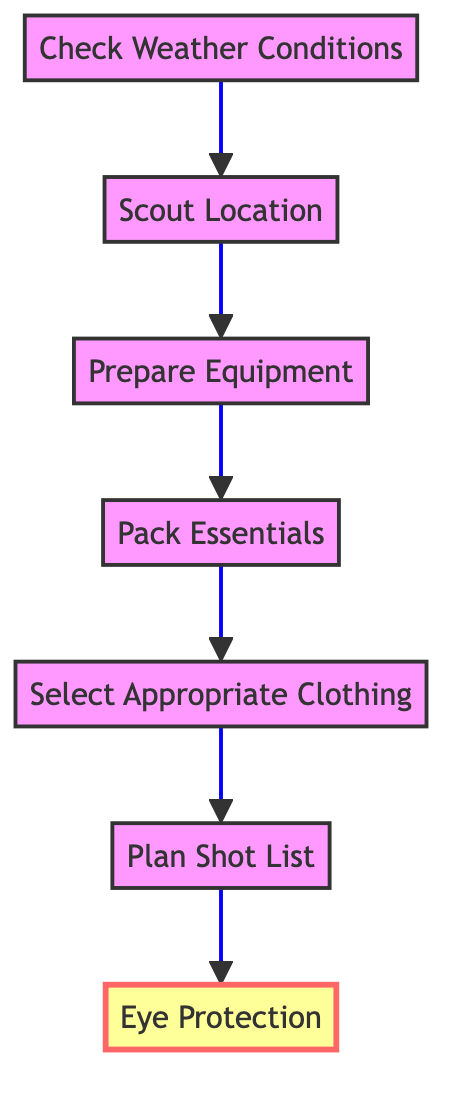What is the first step in the outdoor photoshoot preparation? The first step listed in the diagram is "Check Weather Conditions." This is the initial action that needs to be taken before proceeding to the next steps.
Answer: Check Weather Conditions How many steps are shown in the diagram? There are a total of seven steps illustrated in the diagram. Each step is represented by a node connected in a sequence, starting from "Check Weather Conditions" and ending with "Eye Protection."
Answer: Seven What comes immediately after "Pack Essentials"? The step that comes after "Pack Essentials" is "Select Appropriate Clothing." The sequence in the diagram flows directly from one step to the next.
Answer: Select Appropriate Clothing Which step emphasizes eye protection? The step "Eye Protection" is emphasized in the diagram. It has a bold font and is marked with a special style indicating its importance in the preparation process.
Answer: Eye Protection What relationship exists between "Prepare Equipment" and "Pack Essentials"? The relationship is sequential; "Prepare Equipment" directly leads to "Pack Essentials" as the steps flow from one to the other in a bottom-to-up manner in the diagram.
Answer: Sequential What step includes the suggestion to wear hats and sunglasses? The suggestion to wear hats and sunglasses is included in the step "Select Appropriate Clothing." This step focuses on choosing clothing that is comfortable and appropriate for the weather.
Answer: Select Appropriate Clothing Which node has the largest font size? The node with the largest font size is "Eye Protection." It is designed to stand out, indicating its critical importance in the overall preparation process.
Answer: Eye Protection What does the flowchart suggest is crucial after selecting clothing? After selecting clothing, the next crucial step is "Plan Shot List." This emphasizes the importance of having a clear plan for the photoshoot right after ensuring proper attire.
Answer: Plan Shot List 